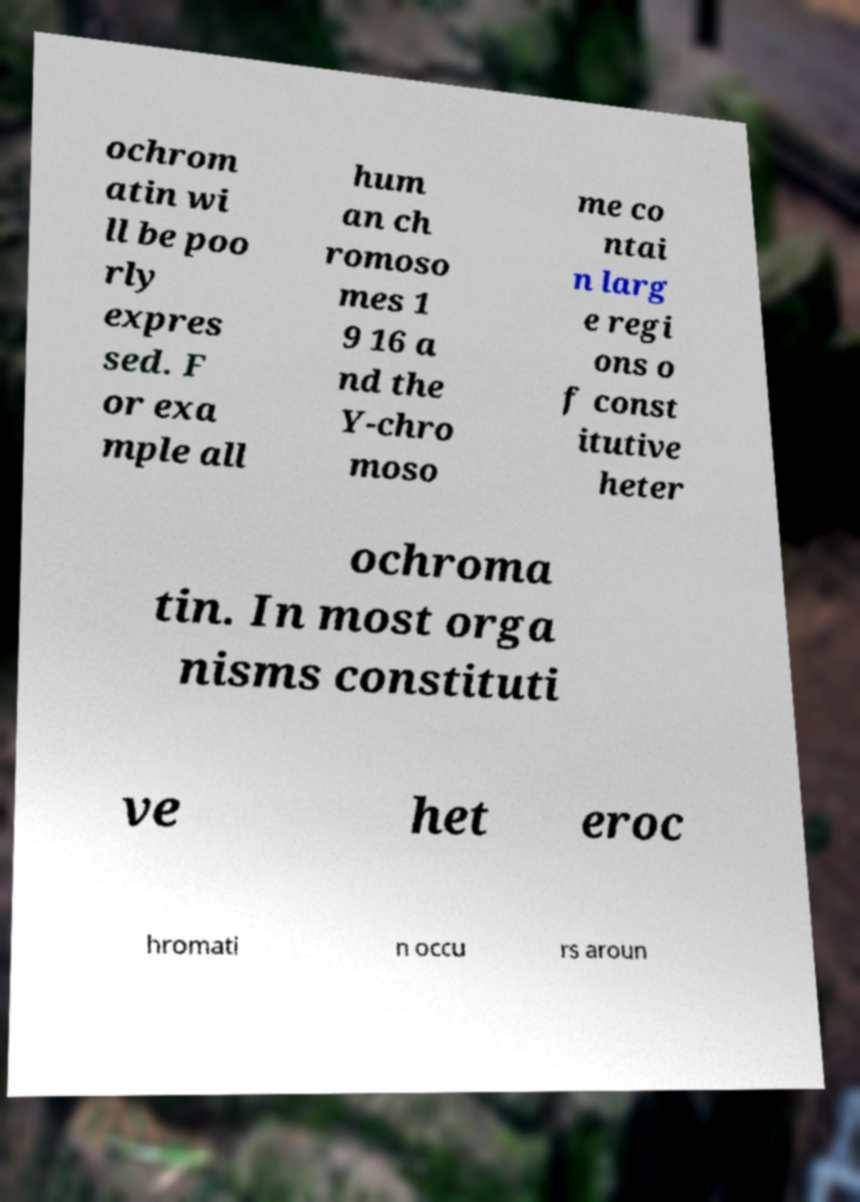Can you accurately transcribe the text from the provided image for me? ochrom atin wi ll be poo rly expres sed. F or exa mple all hum an ch romoso mes 1 9 16 a nd the Y-chro moso me co ntai n larg e regi ons o f const itutive heter ochroma tin. In most orga nisms constituti ve het eroc hromati n occu rs aroun 